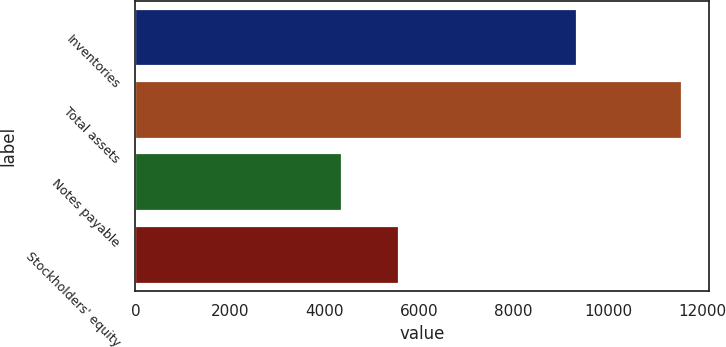Convert chart to OTSL. <chart><loc_0><loc_0><loc_500><loc_500><bar_chart><fcel>Inventories<fcel>Total assets<fcel>Notes payable<fcel>Stockholders' equity<nl><fcel>9343.5<fcel>11556.3<fcel>4376.8<fcel>5586.9<nl></chart> 